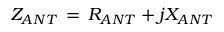<formula> <loc_0><loc_0><loc_500><loc_500>Z _ { A N T } \, = \, R _ { A N T } + j X _ { A N T }</formula> 